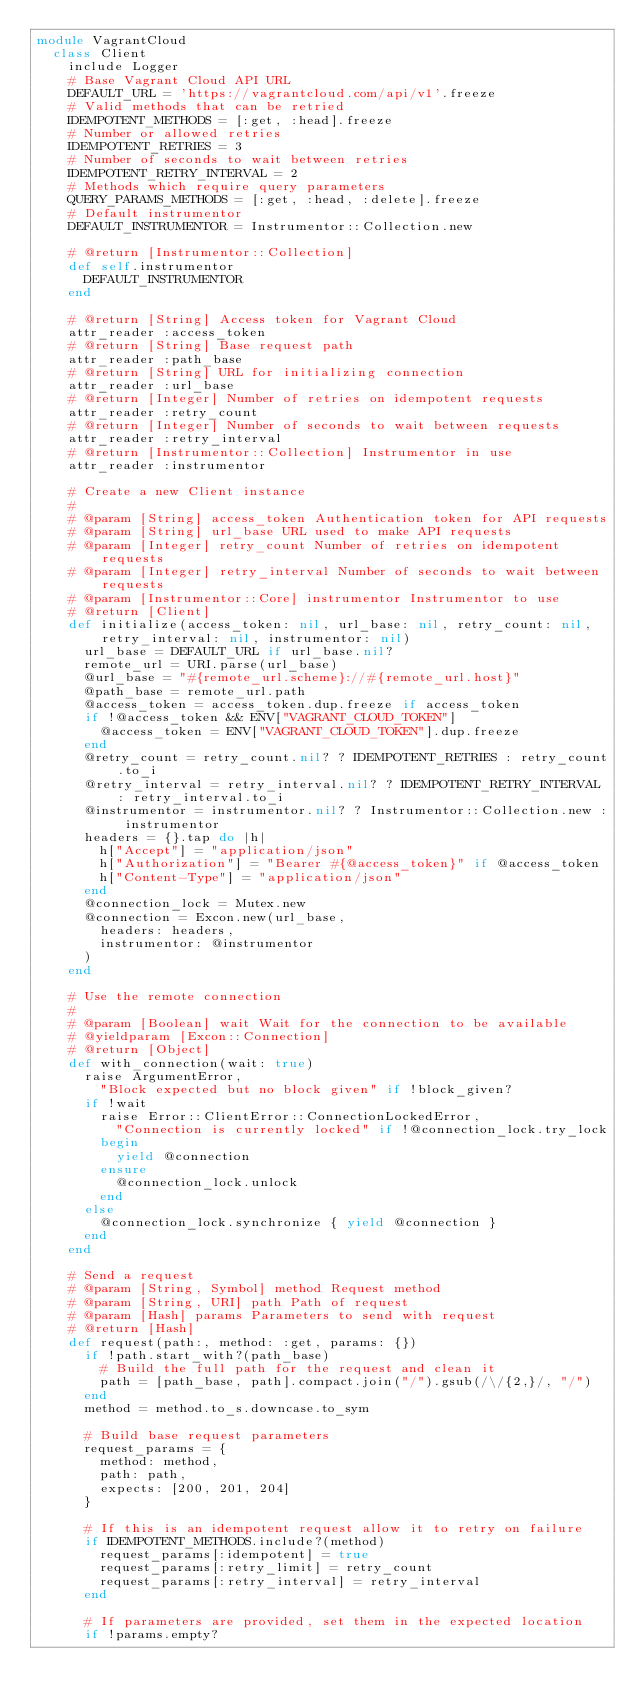Convert code to text. <code><loc_0><loc_0><loc_500><loc_500><_Ruby_>module VagrantCloud
  class Client
    include Logger
    # Base Vagrant Cloud API URL
    DEFAULT_URL = 'https://vagrantcloud.com/api/v1'.freeze
    # Valid methods that can be retried
    IDEMPOTENT_METHODS = [:get, :head].freeze
    # Number or allowed retries
    IDEMPOTENT_RETRIES = 3
    # Number of seconds to wait between retries
    IDEMPOTENT_RETRY_INTERVAL = 2
    # Methods which require query parameters
    QUERY_PARAMS_METHODS = [:get, :head, :delete].freeze
    # Default instrumentor
    DEFAULT_INSTRUMENTOR = Instrumentor::Collection.new

    # @return [Instrumentor::Collection]
    def self.instrumentor
      DEFAULT_INSTRUMENTOR
    end

    # @return [String] Access token for Vagrant Cloud
    attr_reader :access_token
    # @return [String] Base request path
    attr_reader :path_base
    # @return [String] URL for initializing connection
    attr_reader :url_base
    # @return [Integer] Number of retries on idempotent requests
    attr_reader :retry_count
    # @return [Integer] Number of seconds to wait between requests
    attr_reader :retry_interval
    # @return [Instrumentor::Collection] Instrumentor in use
    attr_reader :instrumentor

    # Create a new Client instance
    #
    # @param [String] access_token Authentication token for API requests
    # @param [String] url_base URL used to make API requests
    # @param [Integer] retry_count Number of retries on idempotent requests
    # @param [Integer] retry_interval Number of seconds to wait between requests
    # @param [Instrumentor::Core] instrumentor Instrumentor to use
    # @return [Client]
    def initialize(access_token: nil, url_base: nil, retry_count: nil, retry_interval: nil, instrumentor: nil)
      url_base = DEFAULT_URL if url_base.nil?
      remote_url = URI.parse(url_base)
      @url_base = "#{remote_url.scheme}://#{remote_url.host}"
      @path_base = remote_url.path
      @access_token = access_token.dup.freeze if access_token
      if !@access_token && ENV["VAGRANT_CLOUD_TOKEN"]
        @access_token = ENV["VAGRANT_CLOUD_TOKEN"].dup.freeze
      end
      @retry_count = retry_count.nil? ? IDEMPOTENT_RETRIES : retry_count.to_i
      @retry_interval = retry_interval.nil? ? IDEMPOTENT_RETRY_INTERVAL : retry_interval.to_i
      @instrumentor = instrumentor.nil? ? Instrumentor::Collection.new : instrumentor
      headers = {}.tap do |h|
        h["Accept"] = "application/json"
        h["Authorization"] = "Bearer #{@access_token}" if @access_token
        h["Content-Type"] = "application/json"
      end
      @connection_lock = Mutex.new
      @connection = Excon.new(url_base,
        headers: headers,
        instrumentor: @instrumentor
      )
    end

    # Use the remote connection
    #
    # @param [Boolean] wait Wait for the connection to be available
    # @yieldparam [Excon::Connection]
    # @return [Object]
    def with_connection(wait: true)
      raise ArgumentError,
        "Block expected but no block given" if !block_given?
      if !wait
        raise Error::ClientError::ConnectionLockedError,
          "Connection is currently locked" if !@connection_lock.try_lock
        begin
          yield @connection
        ensure
          @connection_lock.unlock
        end
      else
        @connection_lock.synchronize { yield @connection }
      end
    end

    # Send a request
    # @param [String, Symbol] method Request method
    # @param [String, URI] path Path of request
    # @param [Hash] params Parameters to send with request
    # @return [Hash]
    def request(path:, method: :get, params: {})
      if !path.start_with?(path_base)
        # Build the full path for the request and clean it
        path = [path_base, path].compact.join("/").gsub(/\/{2,}/, "/")
      end
      method = method.to_s.downcase.to_sym

      # Build base request parameters
      request_params = {
        method: method,
        path: path,
        expects: [200, 201, 204]
      }

      # If this is an idempotent request allow it to retry on failure
      if IDEMPOTENT_METHODS.include?(method)
        request_params[:idempotent] = true
        request_params[:retry_limit] = retry_count
        request_params[:retry_interval] = retry_interval
      end

      # If parameters are provided, set them in the expected location
      if !params.empty?</code> 